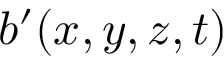Convert formula to latex. <formula><loc_0><loc_0><loc_500><loc_500>b ^ { \prime } ( x , y , z , t )</formula> 